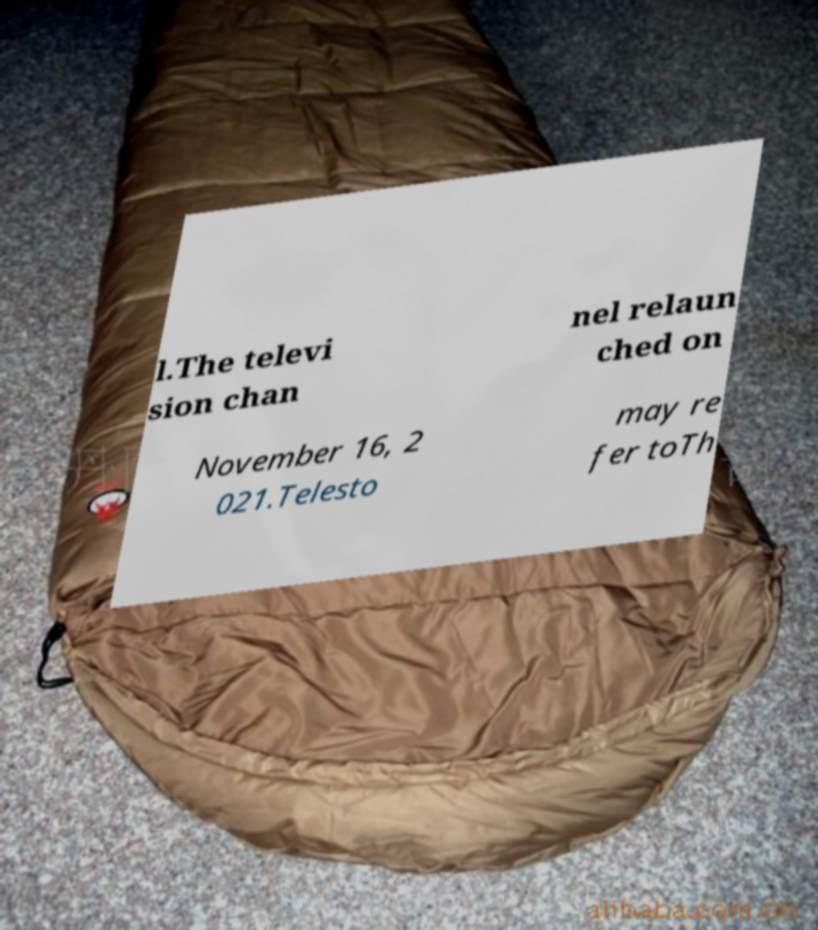What messages or text are displayed in this image? I need them in a readable, typed format. l.The televi sion chan nel relaun ched on November 16, 2 021.Telesto may re fer toTh 